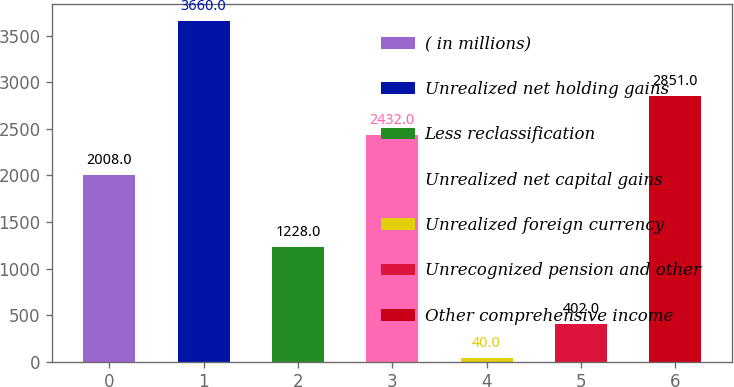Convert chart to OTSL. <chart><loc_0><loc_0><loc_500><loc_500><bar_chart><fcel>( in millions)<fcel>Unrealized net holding gains<fcel>Less reclassification<fcel>Unrealized net capital gains<fcel>Unrealized foreign currency<fcel>Unrecognized pension and other<fcel>Other comprehensive income<nl><fcel>2008<fcel>3660<fcel>1228<fcel>2432<fcel>40<fcel>402<fcel>2851<nl></chart> 